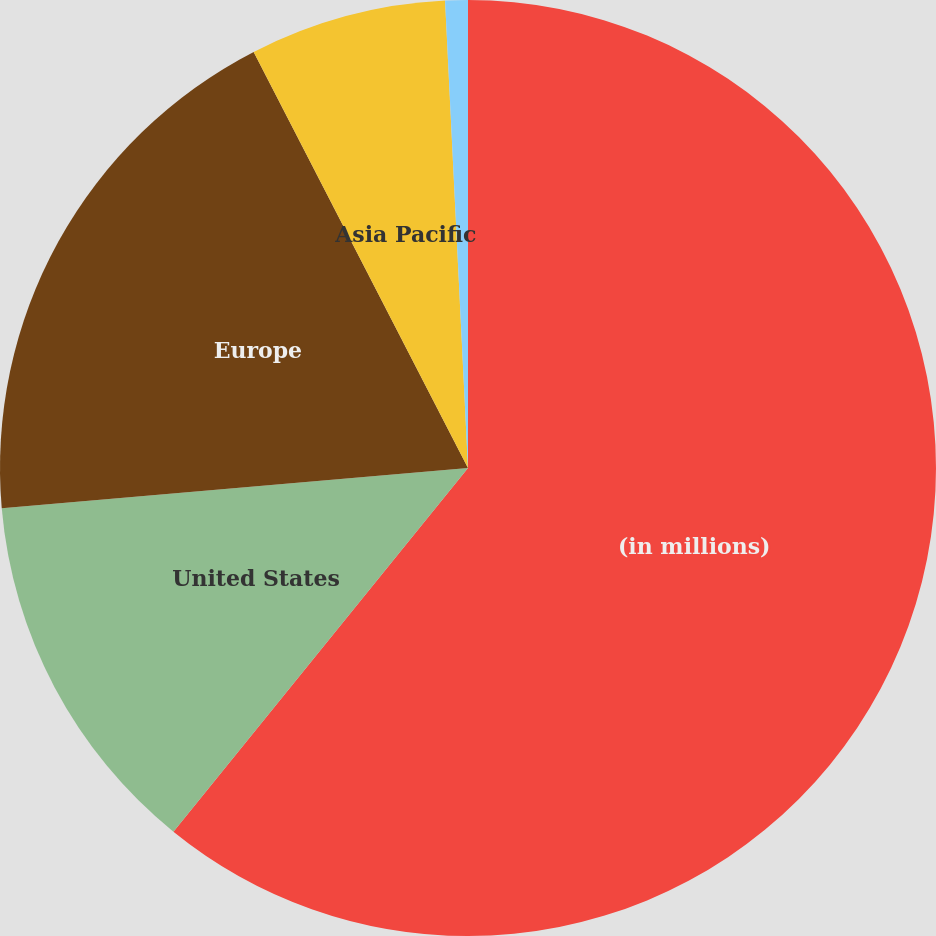Convert chart to OTSL. <chart><loc_0><loc_0><loc_500><loc_500><pie_chart><fcel>(in millions)<fcel>United States<fcel>Europe<fcel>Asia Pacific<fcel>Other<nl><fcel>60.83%<fcel>12.79%<fcel>18.8%<fcel>6.79%<fcel>0.78%<nl></chart> 